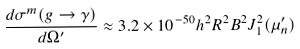<formula> <loc_0><loc_0><loc_500><loc_500>\frac { d \sigma ^ { m } ( g \to \gamma ) } { d \Omega ^ { \prime } } \approx 3 . 2 \times 1 0 ^ { - 5 0 } h ^ { 2 } R ^ { 2 } B ^ { 2 } J _ { 1 } ^ { 2 } ( \mu ^ { \prime } _ { n } )</formula> 